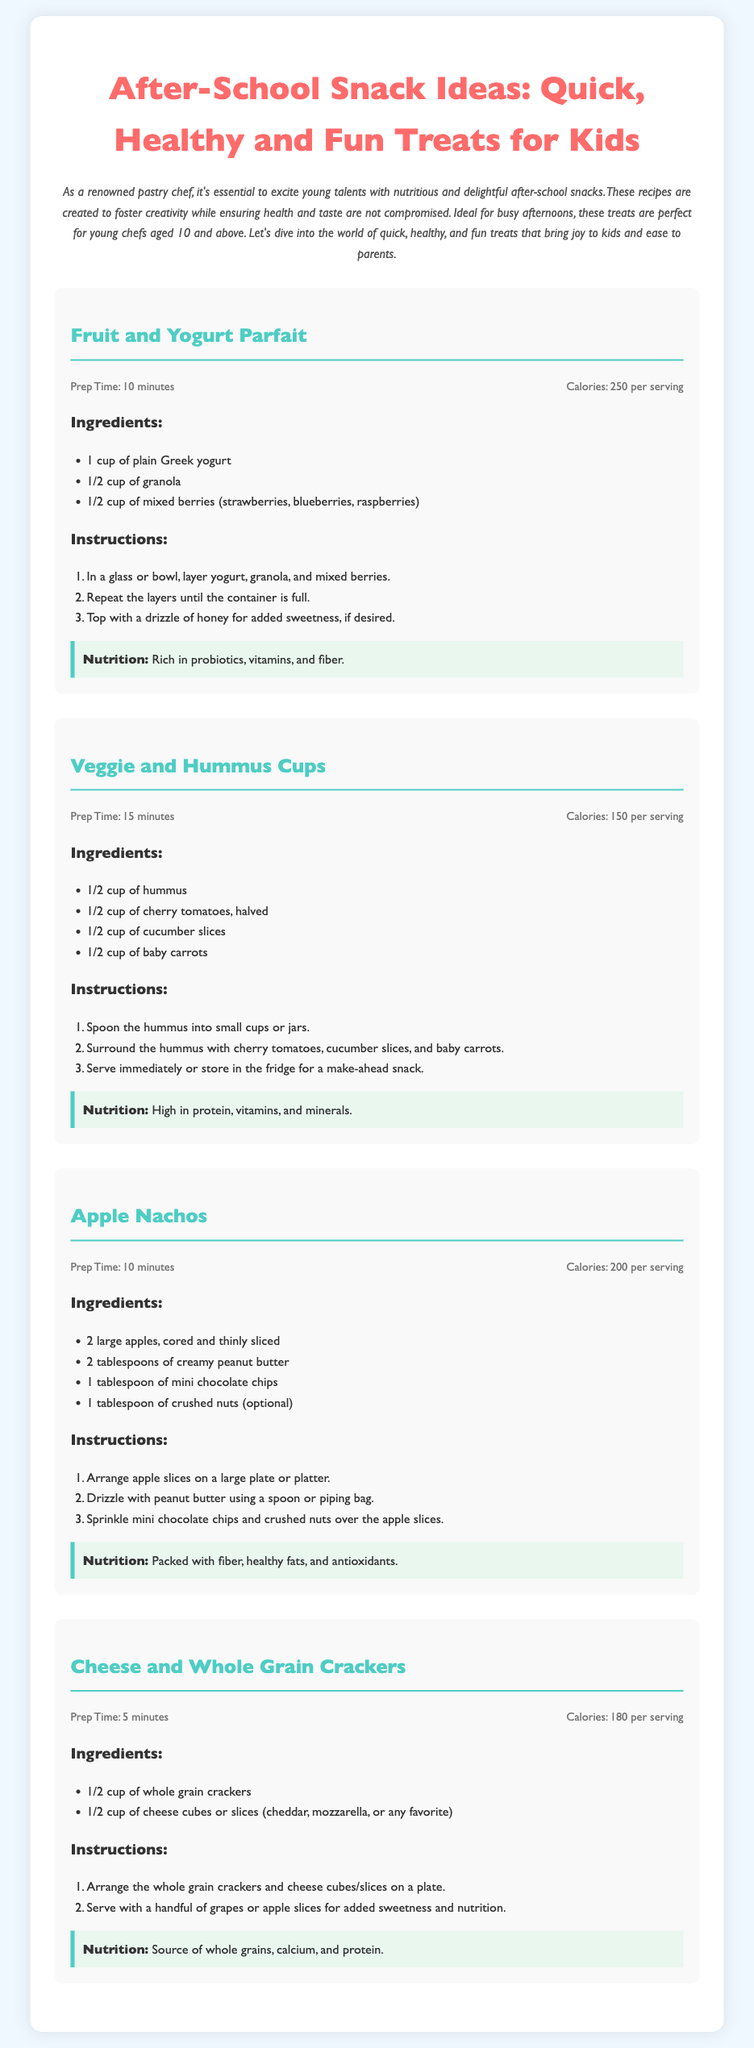What is the title of the document? The title appears prominently at the top of the document, providing the main topic.
Answer: After-School Snack Ideas: Quick, Healthy and Fun Treats for Kids How many snacks are featured in the document? The document contains four distinct snack recipes listed.
Answer: Four What is the prep time for the Veggie and Hummus Cups? The prep time is provided in the recipe details for each snack.
Answer: 15 minutes Which recipe contains mixed berries? The recipe list describes specific ingredients for each dish, and mixed berries are found in one.
Answer: Fruit and Yogurt Parfait What is the calorie count for Apple Nachos? The document lists calorie information for each snack recipe.
Answer: 200 per serving What is the main source of protein in Cheese and Whole Grain Crackers? The document identifies ingredients, and cheese is known to be a protein source in this particular recipe.
Answer: Cheese Which snack has the lowest calorie count? Comparing calorie counts across the recipes will reveal which one is lowest.
Answer: Veggie and Hummus Cups What is one of the optional toppings for Apple Nachos? The recipe specifies optional ingredients that can be added to enhance flavor or texture.
Answer: Crushed nuts 